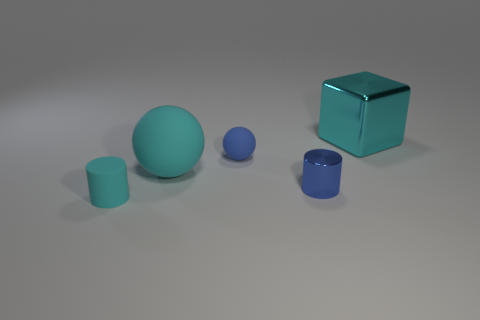There is a thing that is both in front of the big cyan ball and on the right side of the large matte thing; what is its color?
Provide a short and direct response. Blue. There is a cyan metallic thing; is its size the same as the cylinder that is on the right side of the blue ball?
Keep it short and to the point. No. There is a small rubber thing that is to the right of the cyan sphere; what is its shape?
Offer a very short reply. Sphere. Are there more small cylinders behind the cyan cylinder than small purple rubber cylinders?
Provide a short and direct response. Yes. How many cyan shiny cubes are in front of the cyan thing that is behind the blue thing that is behind the tiny shiny thing?
Offer a very short reply. 0. There is a cyan rubber thing behind the small shiny object; is its size the same as the shiny object behind the tiny metal object?
Your answer should be very brief. Yes. What is the material of the large cyan object to the left of the big cyan block behind the large cyan rubber sphere?
Provide a succinct answer. Rubber. What number of objects are cyan things behind the small ball or metal cylinders?
Your response must be concise. 2. Are there an equal number of rubber balls on the right side of the blue cylinder and small rubber spheres to the right of the big cyan metallic object?
Ensure brevity in your answer.  Yes. What material is the small cylinder behind the small cylinder on the left side of the shiny object that is in front of the metal cube?
Provide a succinct answer. Metal. 